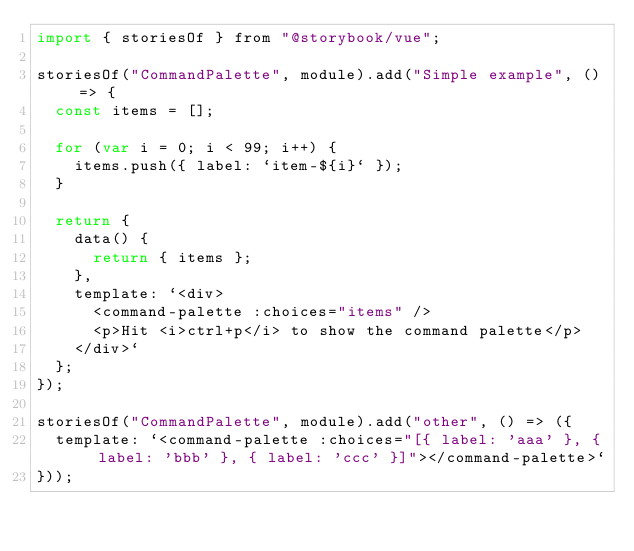Convert code to text. <code><loc_0><loc_0><loc_500><loc_500><_JavaScript_>import { storiesOf } from "@storybook/vue";

storiesOf("CommandPalette", module).add("Simple example", () => {
  const items = [];

  for (var i = 0; i < 99; i++) {
    items.push({ label: `item-${i}` });
  }

  return {
    data() {
      return { items };
    },
    template: `<div>
      <command-palette :choices="items" />
      <p>Hit <i>ctrl+p</i> to show the command palette</p>
    </div>`
  };
});

storiesOf("CommandPalette", module).add("other", () => ({
  template: `<command-palette :choices="[{ label: 'aaa' }, { label: 'bbb' }, { label: 'ccc' }]"></command-palette>`
}));
</code> 